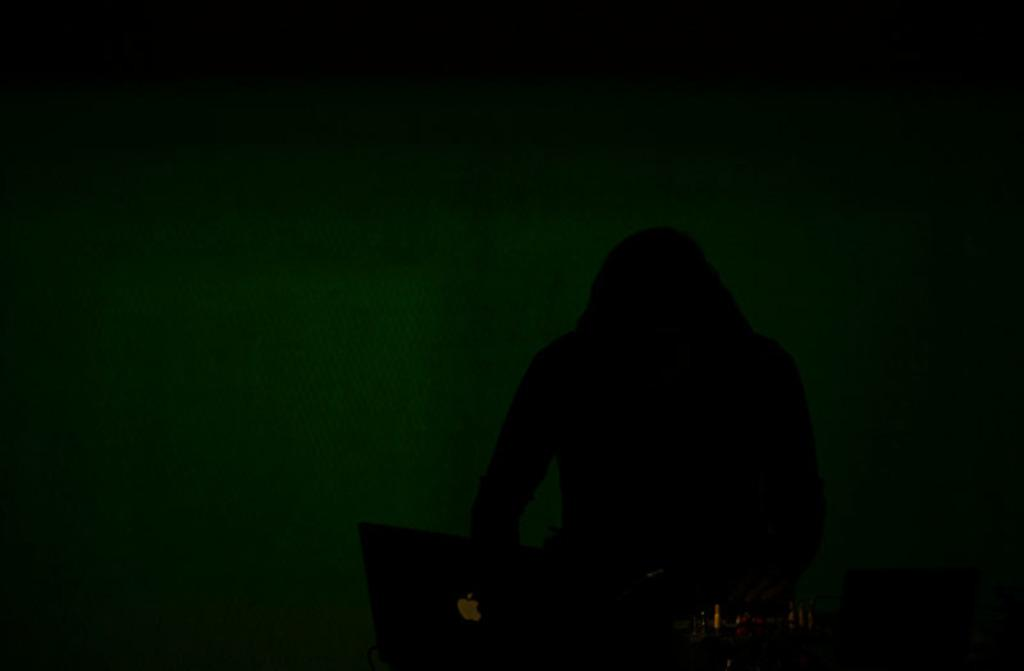What is the main subject of the image? There is a person in the image. What object is visible in the image alongside the person? There is a laptop in the image. Can you describe any other items or objects in the image? There are unspecified "things" in the image. What type of plastic is the queen using to pay off her debt in the image? There is no queen or debt present in the image, and therefore no plastic or payment can be observed. 